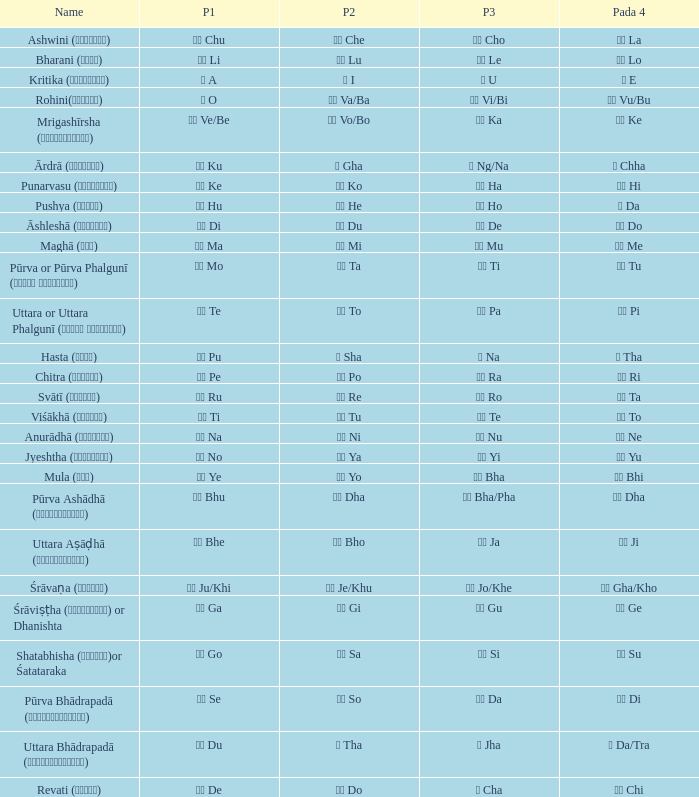Which pada 4 has a pada 2 of थ tha? ञ Da/Tra. 